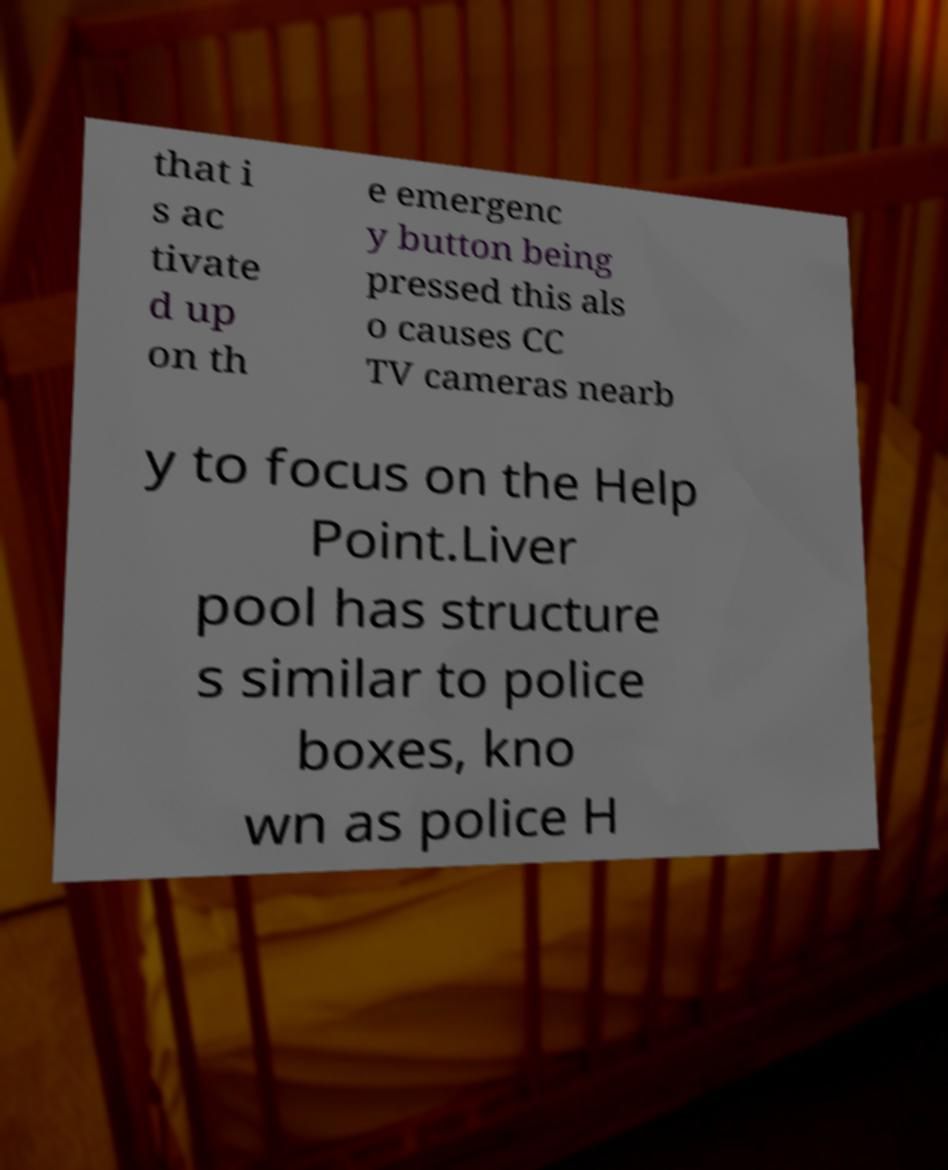Please read and relay the text visible in this image. What does it say? that i s ac tivate d up on th e emergenc y button being pressed this als o causes CC TV cameras nearb y to focus on the Help Point.Liver pool has structure s similar to police boxes, kno wn as police H 